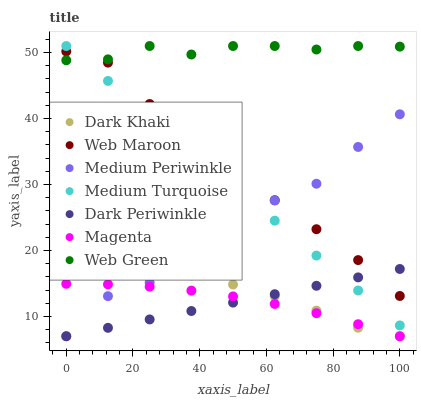Does Dark Periwinkle have the minimum area under the curve?
Answer yes or no. Yes. Does Web Green have the maximum area under the curve?
Answer yes or no. Yes. Does Medium Periwinkle have the minimum area under the curve?
Answer yes or no. No. Does Medium Periwinkle have the maximum area under the curve?
Answer yes or no. No. Is Dark Periwinkle the smoothest?
Answer yes or no. Yes. Is Medium Periwinkle the roughest?
Answer yes or no. Yes. Is Web Green the smoothest?
Answer yes or no. No. Is Web Green the roughest?
Answer yes or no. No. Does Medium Periwinkle have the lowest value?
Answer yes or no. Yes. Does Web Green have the lowest value?
Answer yes or no. No. Does Medium Turquoise have the highest value?
Answer yes or no. Yes. Does Medium Periwinkle have the highest value?
Answer yes or no. No. Is Magenta less than Medium Turquoise?
Answer yes or no. Yes. Is Web Green greater than Dark Periwinkle?
Answer yes or no. Yes. Does Dark Periwinkle intersect Web Maroon?
Answer yes or no. Yes. Is Dark Periwinkle less than Web Maroon?
Answer yes or no. No. Is Dark Periwinkle greater than Web Maroon?
Answer yes or no. No. Does Magenta intersect Medium Turquoise?
Answer yes or no. No. 